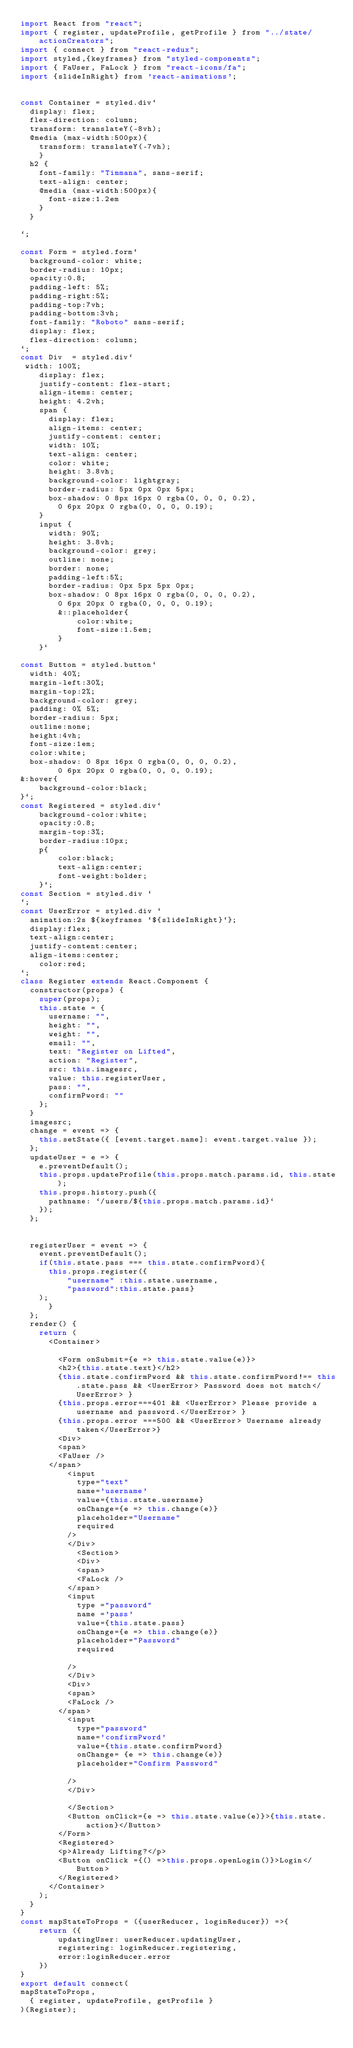<code> <loc_0><loc_0><loc_500><loc_500><_JavaScript_>import React from "react";
import { register, updateProfile, getProfile } from "../state/actionCreators";
import { connect } from "react-redux";
import styled,{keyframes} from "styled-components";
import { FaUser, FaLock } from "react-icons/fa";
import {slideInRight} from 'react-animations';


const Container = styled.div`
  display: flex;
  flex-direction: column;
  transform: translateY(-8vh);
  @media (max-width:500px){
    transform: translateY(-7vh);
    }
  h2 {
    font-family: "Timmana", sans-serif;
    text-align: center;
    @media (max-width:500px){
      font-size:1.2em
    }
  }

`;

const Form = styled.form`
  background-color: white;
  border-radius: 10px;
  opacity:0.8;
  padding-left: 5%;
  padding-right:5%;
  padding-top:7vh;
  padding-bottom:3vh;
  font-family: "Roboto" sans-serif;
  display: flex;
  flex-direction: column;
`;
const Div  = styled.div`
 width: 100%;
    display: flex;
    justify-content: flex-start;
    align-items: center;
    height: 4.2vh;
    span {
      display: flex;
      align-items: center;
      justify-content: center;
      width: 10%;
      text-align: center;
      color: white;
      height: 3.8vh;
      background-color: lightgray;
      border-radius: 5px 0px 0px 5px;
      box-shadow: 0 8px 16px 0 rgba(0, 0, 0, 0.2),
        0 6px 20px 0 rgba(0, 0, 0, 0.19);
    }
    input {
      width: 90%;
      height: 3.8vh;
      background-color: grey;
      outline: none;
      border: none;
      padding-left:5%;
      border-radius: 0px 5px 5px 0px;
      box-shadow: 0 8px 16px 0 rgba(0, 0, 0, 0.2),
        0 6px 20px 0 rgba(0, 0, 0, 0.19);
        &::placeholder{
            color:white;
            font-size:1.5em;
        }
    }`

const Button = styled.button`
  width: 40%;
  margin-left:30%;
  margin-top:2%;
  background-color: grey;
  padding: 0% 5%;
  border-radius: 5px;
  outline:none;
  height:4vh;
  font-size:1em;
  color:white;
  box-shadow: 0 8px 16px 0 rgba(0, 0, 0, 0.2),
        0 6px 20px 0 rgba(0, 0, 0, 0.19);
&:hover{
    background-color:black;
}`;
const Registered = styled.div`
    background-color:white;
    opacity:0.8;
    margin-top:3%;
    border-radius:10px;
    p{
        color:black;
        text-align:center;
        font-weight:bolder;
    }`;
const Section = styled.div `
`;
const UserError = styled.div `
  animation:2s ${keyframes `${slideInRight}`};
  display:flex;
  text-align:center;
  justify-content:center;
  align-items:center;
    color:red;
`;
class Register extends React.Component {
  constructor(props) {
    super(props);
    this.state = {
      username: "",
      height: "",
      weight: "",
      email: "",
      text: "Register on Lifted",
      action: "Register",
      src: this.imagesrc,
      value: this.registerUser,
      pass: "",
      confirmPword: ""
    };
  }
  imagesrc;
  change = event => {
    this.setState({ [event.target.name]: event.target.value });
  };
  updateUser = e => {
    e.preventDefault();
    this.props.updateProfile(this.props.match.params.id, this.state);
    this.props.history.push({
      pathname: `/users/${this.props.match.params.id}`
    });
  };


  registerUser = event => {
    event.preventDefault();
    if(this.state.pass === this.state.confirmPword){
      this.props.register({
          "username" :this.state.username, 
          "password":this.state.pass}
    );
      }
  };
  render() {
    return (
      <Container>
     
        <Form onSubmit={e => this.state.value(e)}>
        <h2>{this.state.text}</h2>
        {this.state.confirmPword && this.state.confirmPword!== this.state.pass && <UserError> Password does not match</UserError> }
        {this.props.error===401 && <UserError> Please provide a username and password.</UserError> }
        {this.props.error ===500 && <UserError> Username already taken</UserError>}
        <Div>
        <span>
        <FaUser />
      </span>
          <input
            type="text"
            name='username'
            value={this.state.username}
            onChange={e => this.change(e)}
            placeholder="Username"
            required
          />
          </Div>
            <Section>
            <Div>
            <span>
            <FaLock />
          </span>
          <input
            type ="password"
            name ='pass'
            value={this.state.pass}
            onChange={e => this.change(e)}
            placeholder="Password"
            required
       
          />
          </Div>
          <Div>
          <span>
          <FaLock />
        </span>
          <input
            type="password"
            name='confirmPword'
            value={this.state.confirmPword}
            onChange= {e => this.change(e)}
            placeholder="Confirm Password"
    
          />
          </Div>
        
          </Section>
          <Button onClick={e => this.state.value(e)}>{this.state.action}</Button>
        </Form>
        <Registered>
        <p>Already Lifting?</p>
        <Button onClick ={() =>this.props.openLogin()}>Login</Button>
        </Registered>
      </Container>
    );
  }
}
const mapStateToProps = ({userReducer, loginReducer}) =>{
    return ({
        updatingUser: userReducer.updatingUser,
        registering: loginReducer.registering,
        error:loginReducer.error
    })
}
export default connect(
mapStateToProps,
  { register, updateProfile, getProfile }
)(Register);
</code> 